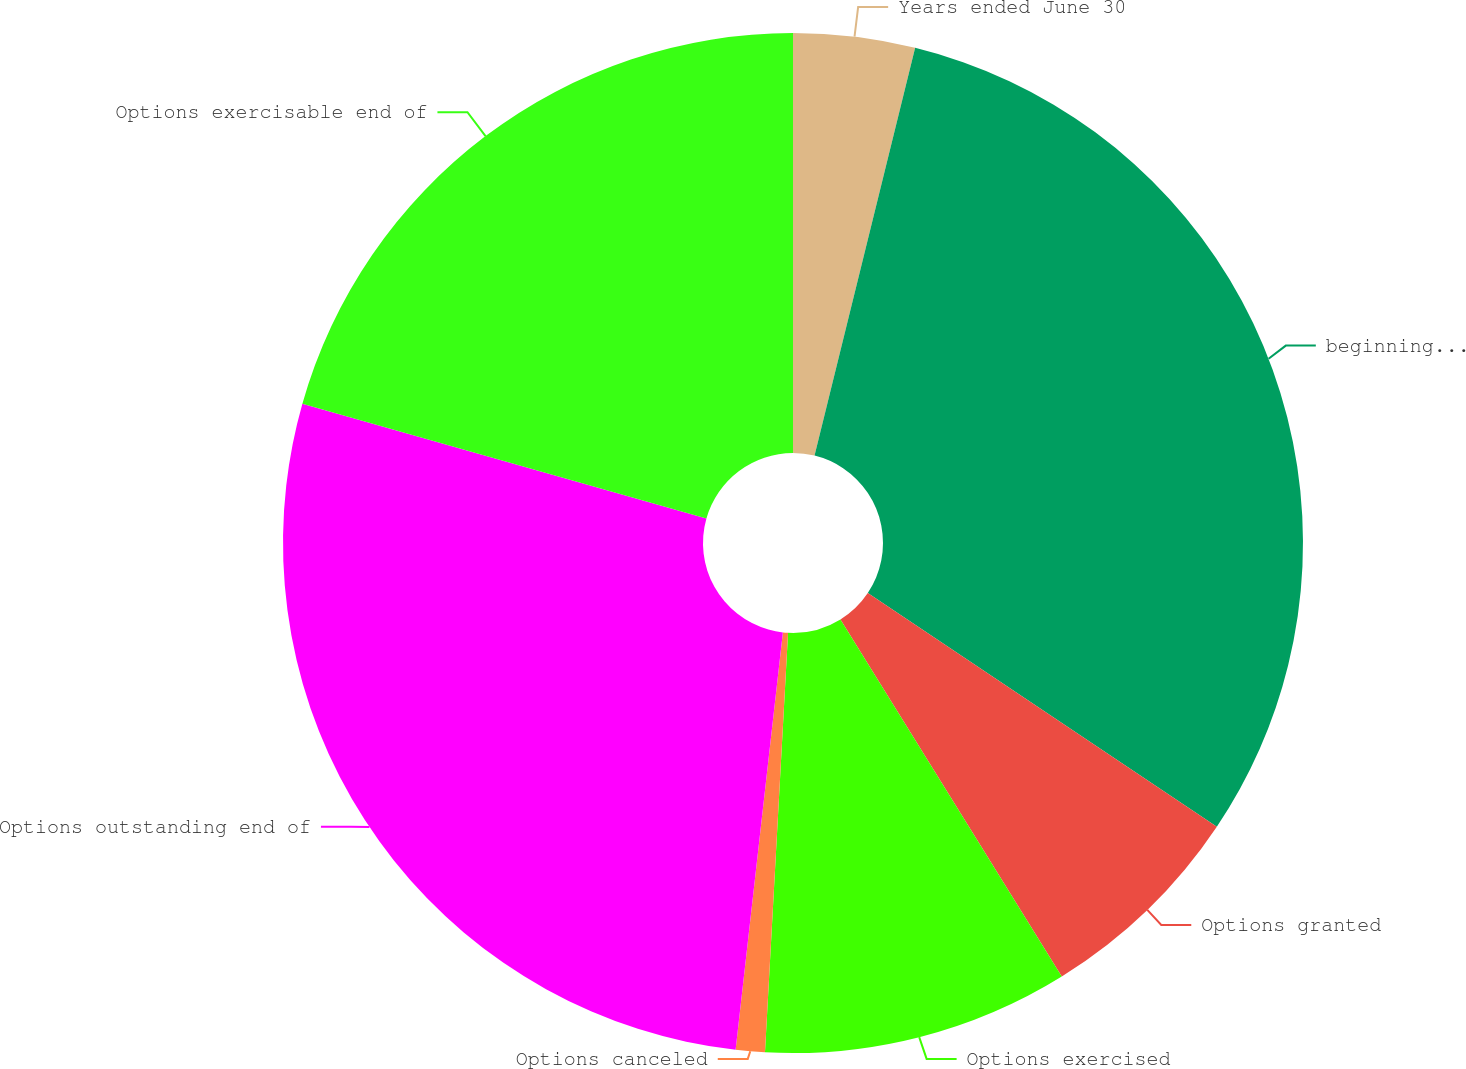<chart> <loc_0><loc_0><loc_500><loc_500><pie_chart><fcel>Years ended June 30<fcel>beginning of year<fcel>Options granted<fcel>Options exercised<fcel>Options canceled<fcel>Options outstanding end of<fcel>Options exercisable end of<nl><fcel>3.85%<fcel>30.54%<fcel>6.78%<fcel>9.71%<fcel>0.92%<fcel>27.61%<fcel>20.6%<nl></chart> 